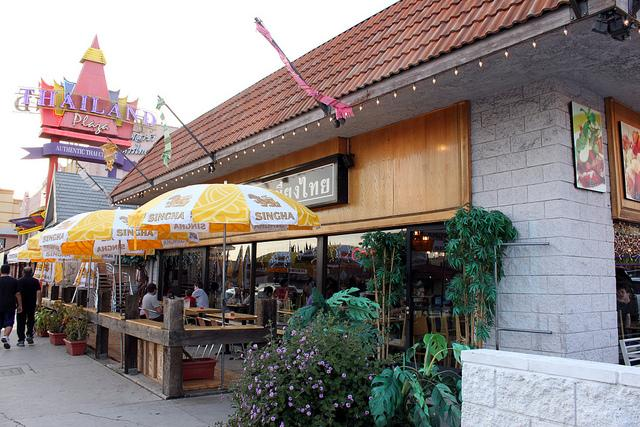What is the capital city of this country? bangkok 